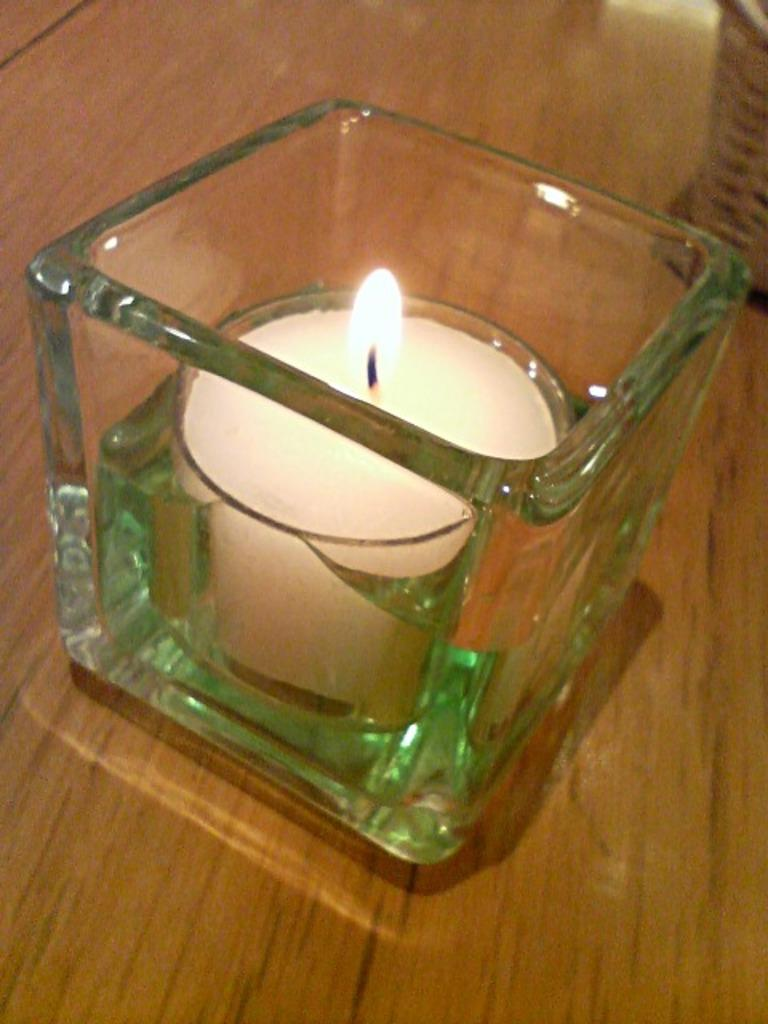What is the main object in the image? There is a candle with a flame in the image. How is the candle contained or protected? The candle is in a glass jar. Where is the glass jar with the candle placed? The glass jar with the candle is placed on a table. What type of fruit is being used as a game piece in the image? There is no fruit or game present in the image; it features a candle in a glass jar on a table. How many nails are visible in the image? There are no nails visible in the image. 